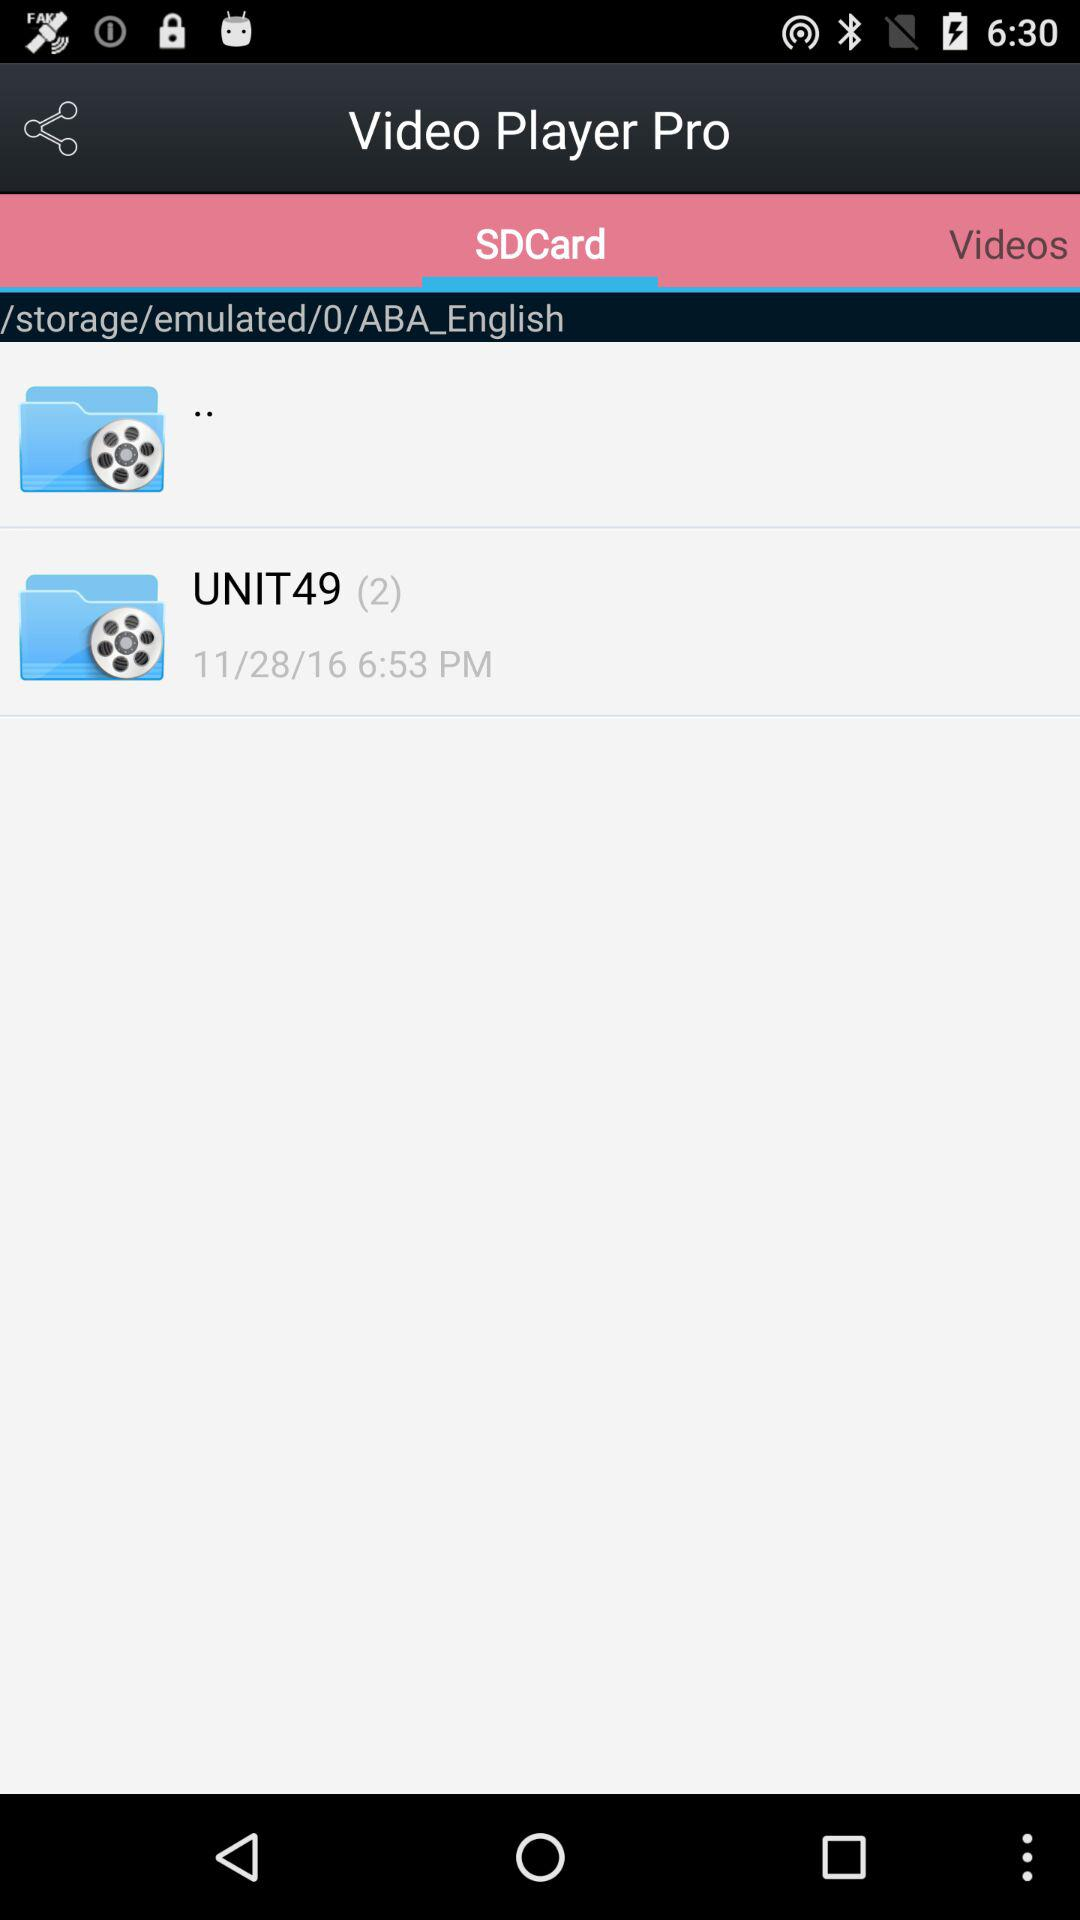How many units are there?
When the provided information is insufficient, respond with <no answer>. <no answer> 